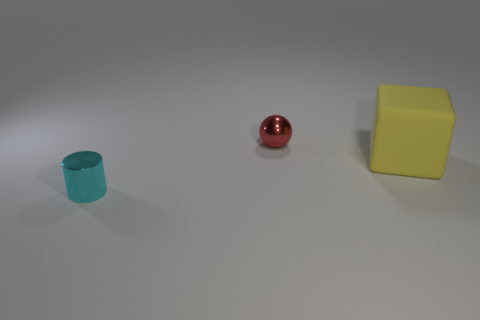Can you tell me what colors are visible in this image? Certainly! The image shows objects in cyan, red, and yellow colors prominently displayed against a neutral gray background. 